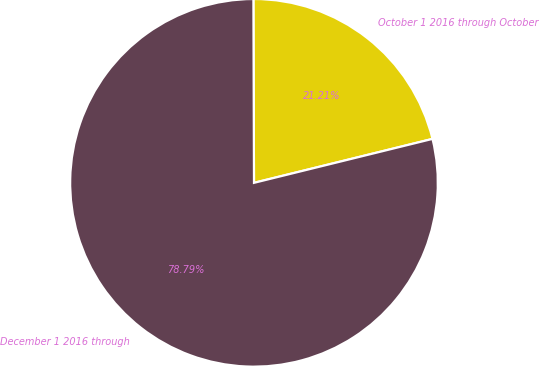Convert chart. <chart><loc_0><loc_0><loc_500><loc_500><pie_chart><fcel>October 1 2016 through October<fcel>December 1 2016 through<nl><fcel>21.21%<fcel>78.79%<nl></chart> 